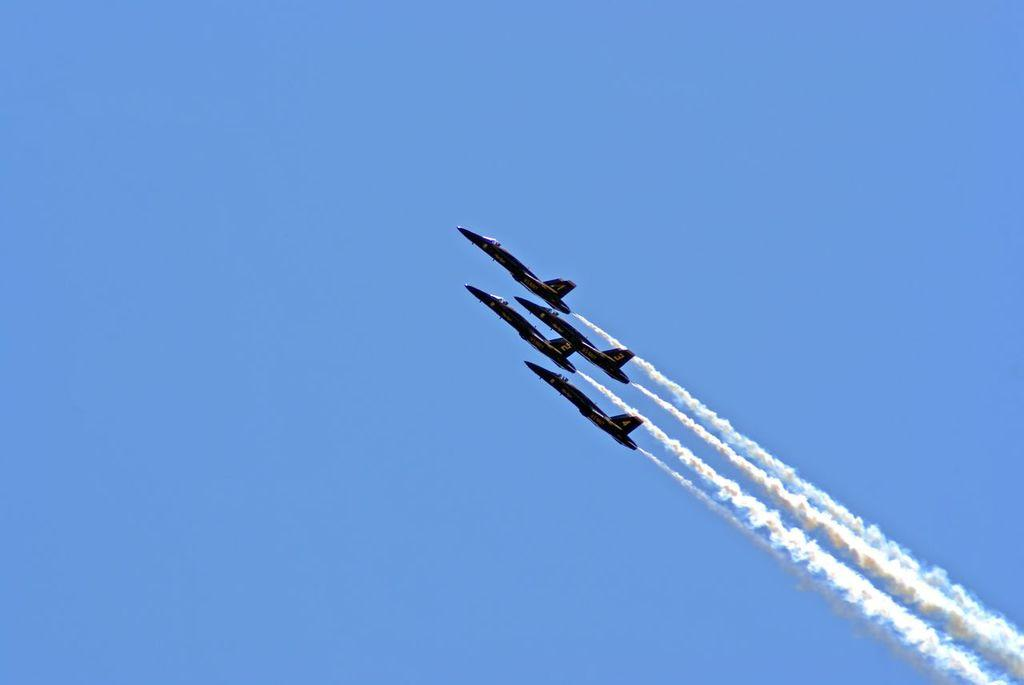What is happening in the sky in the image? There are aircraft flying in the sky. What can be seen as a result of the aircraft flying in the image? There is smoke visible in the image. What type of finger can be seen holding the wren in the image? There is no finger or wren present in the image; it only features aircraft flying in the sky and smoke. 